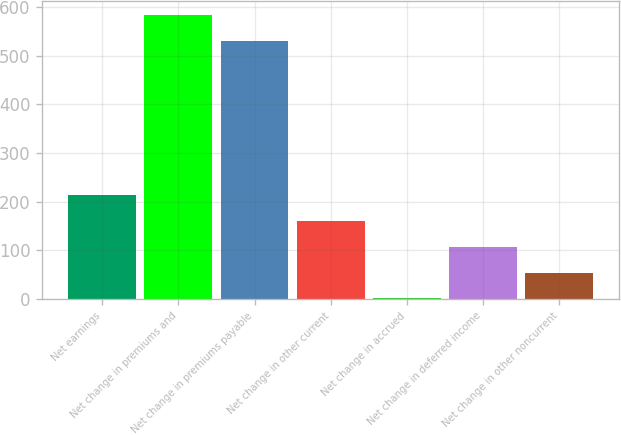Convert chart. <chart><loc_0><loc_0><loc_500><loc_500><bar_chart><fcel>Net earnings<fcel>Net change in premiums and<fcel>Net change in premiums payable<fcel>Net change in other current<fcel>Net change in accrued<fcel>Net change in deferred income<fcel>Net change in other noncurrent<nl><fcel>214.18<fcel>583.17<fcel>529.8<fcel>160.81<fcel>0.7<fcel>107.44<fcel>54.07<nl></chart> 